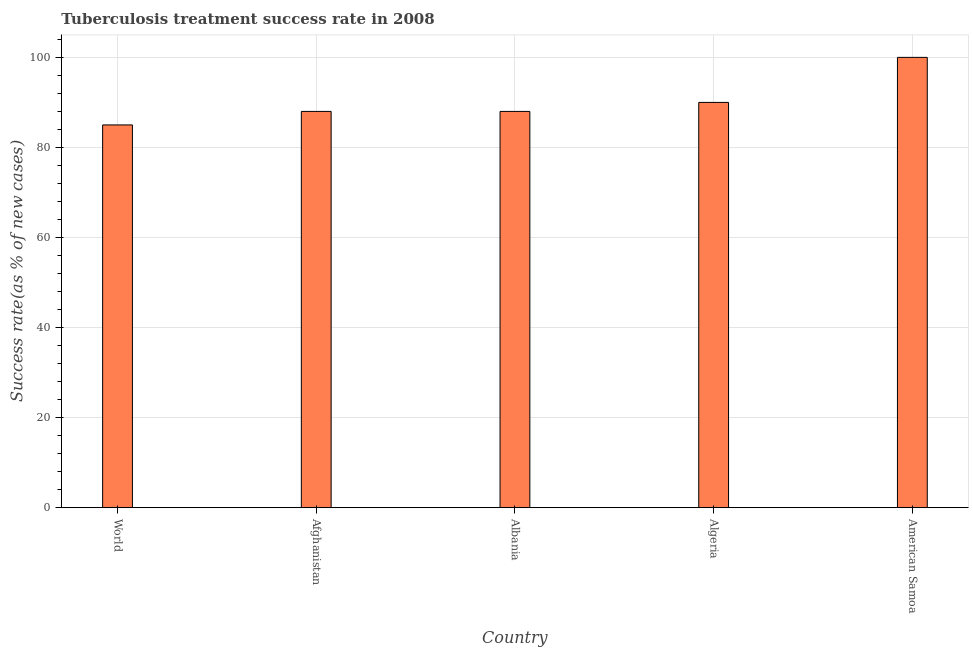What is the title of the graph?
Provide a succinct answer. Tuberculosis treatment success rate in 2008. What is the label or title of the X-axis?
Make the answer very short. Country. What is the label or title of the Y-axis?
Your answer should be compact. Success rate(as % of new cases). Across all countries, what is the minimum tuberculosis treatment success rate?
Offer a terse response. 85. In which country was the tuberculosis treatment success rate maximum?
Ensure brevity in your answer.  American Samoa. What is the sum of the tuberculosis treatment success rate?
Your answer should be very brief. 451. What is the median tuberculosis treatment success rate?
Provide a short and direct response. 88. In how many countries, is the tuberculosis treatment success rate greater than 8 %?
Give a very brief answer. 5. What is the ratio of the tuberculosis treatment success rate in Afghanistan to that in American Samoa?
Offer a very short reply. 0.88. Is the difference between the tuberculosis treatment success rate in Afghanistan and World greater than the difference between any two countries?
Ensure brevity in your answer.  No. What is the difference between the highest and the second highest tuberculosis treatment success rate?
Provide a short and direct response. 10. Are all the bars in the graph horizontal?
Offer a terse response. No. Are the values on the major ticks of Y-axis written in scientific E-notation?
Provide a succinct answer. No. What is the Success rate(as % of new cases) of World?
Your answer should be compact. 85. What is the Success rate(as % of new cases) in Afghanistan?
Your answer should be compact. 88. What is the Success rate(as % of new cases) in Algeria?
Provide a succinct answer. 90. What is the Success rate(as % of new cases) in American Samoa?
Provide a short and direct response. 100. What is the difference between the Success rate(as % of new cases) in World and Afghanistan?
Provide a short and direct response. -3. What is the difference between the Success rate(as % of new cases) in Afghanistan and Albania?
Offer a very short reply. 0. What is the difference between the Success rate(as % of new cases) in Afghanistan and Algeria?
Offer a very short reply. -2. What is the difference between the Success rate(as % of new cases) in Albania and Algeria?
Provide a short and direct response. -2. What is the difference between the Success rate(as % of new cases) in Algeria and American Samoa?
Provide a succinct answer. -10. What is the ratio of the Success rate(as % of new cases) in World to that in Afghanistan?
Your answer should be very brief. 0.97. What is the ratio of the Success rate(as % of new cases) in World to that in Albania?
Ensure brevity in your answer.  0.97. What is the ratio of the Success rate(as % of new cases) in World to that in Algeria?
Provide a succinct answer. 0.94. What is the ratio of the Success rate(as % of new cases) in World to that in American Samoa?
Provide a short and direct response. 0.85. What is the ratio of the Success rate(as % of new cases) in Albania to that in American Samoa?
Make the answer very short. 0.88. 